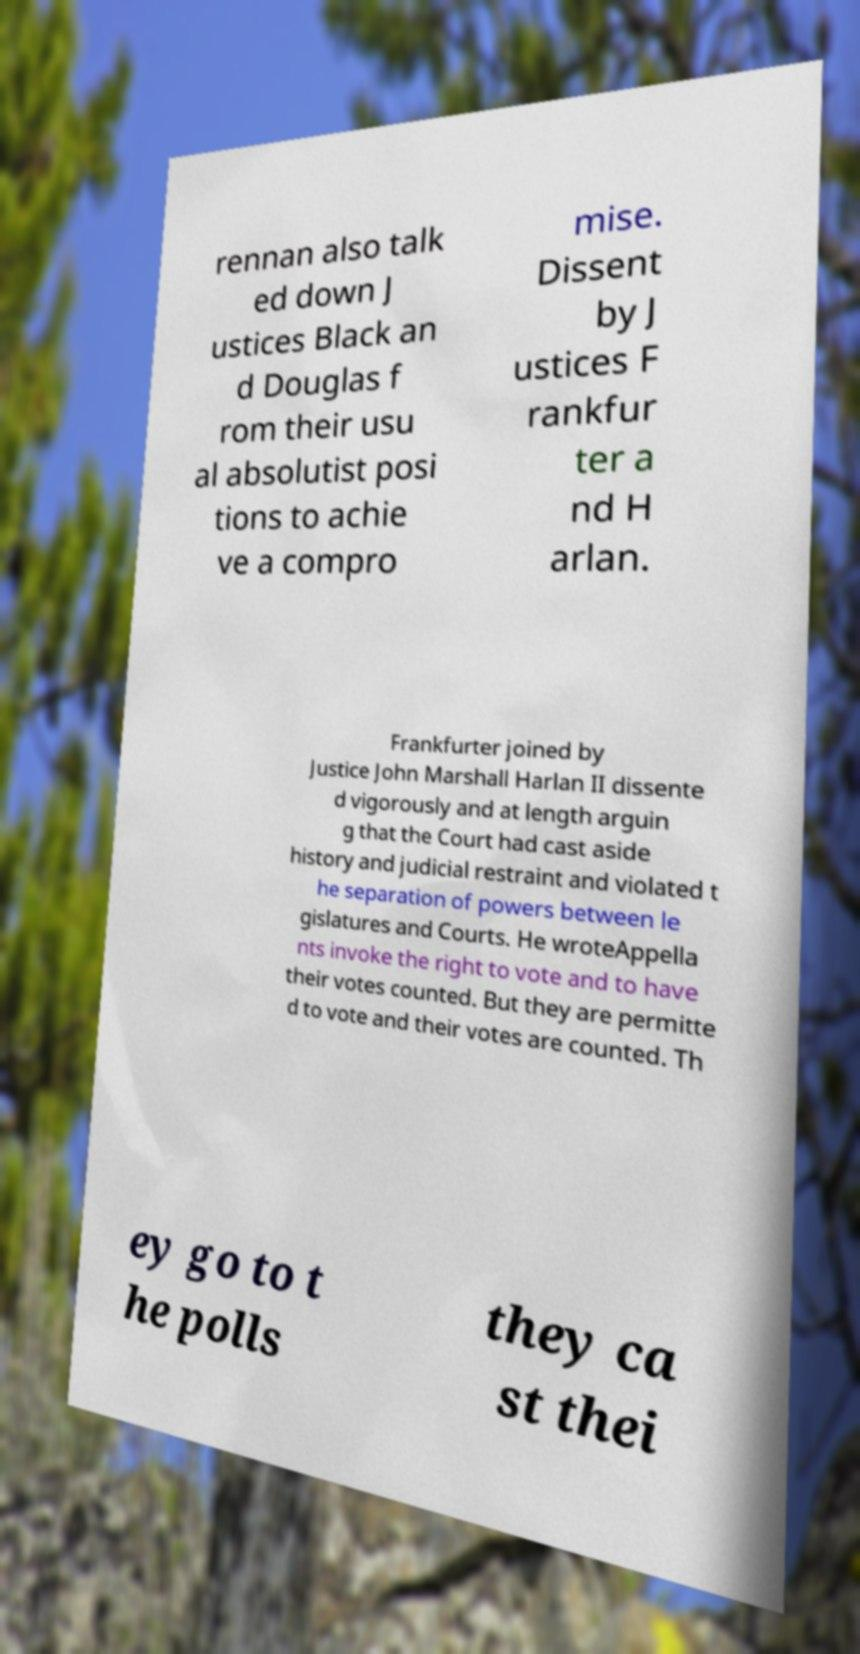Can you read and provide the text displayed in the image?This photo seems to have some interesting text. Can you extract and type it out for me? rennan also talk ed down J ustices Black an d Douglas f rom their usu al absolutist posi tions to achie ve a compro mise. Dissent by J ustices F rankfur ter a nd H arlan. Frankfurter joined by Justice John Marshall Harlan II dissente d vigorously and at length arguin g that the Court had cast aside history and judicial restraint and violated t he separation of powers between le gislatures and Courts. He wroteAppella nts invoke the right to vote and to have their votes counted. But they are permitte d to vote and their votes are counted. Th ey go to t he polls they ca st thei 